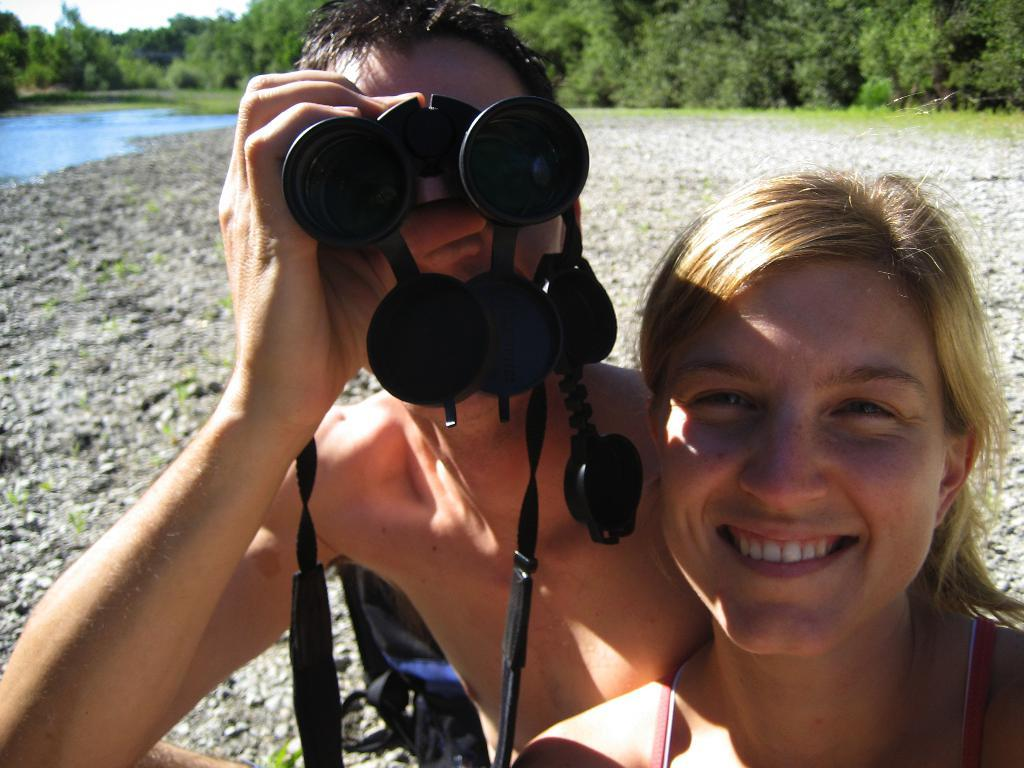How many people are in the image? There are two people in the image. What is the facial expression of the woman in the image? The woman is smiling. What is the other person holding in the image? The other person is holding binoculars. What can be seen in the distance in the image? There are trees and water visible in the distance. What type of trail can be seen in the image? There is no trail visible in the image. How many worms are crawling on the ground in the image? There are no worms present in the image. 